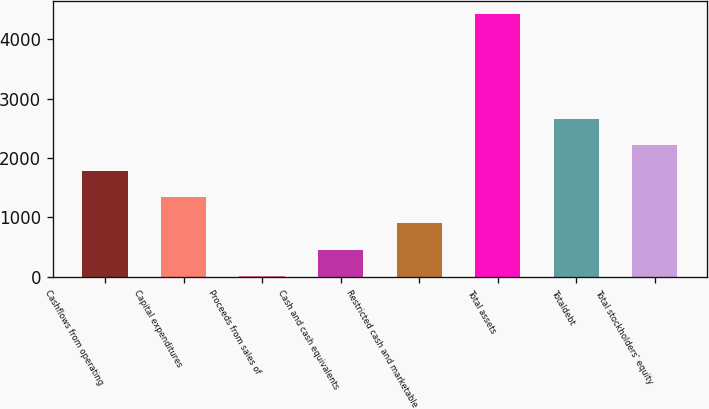Convert chart. <chart><loc_0><loc_0><loc_500><loc_500><bar_chart><fcel>Cashflows from operating<fcel>Capital expenditures<fcel>Proceeds from sales of<fcel>Cash and cash equivalents<fcel>Restricted cash and marketable<fcel>Total assets<fcel>Totaldebt<fcel>Total stockholders' equity<nl><fcel>1782.86<fcel>1341.77<fcel>18.5<fcel>459.59<fcel>900.68<fcel>4429.4<fcel>2665.04<fcel>2223.95<nl></chart> 